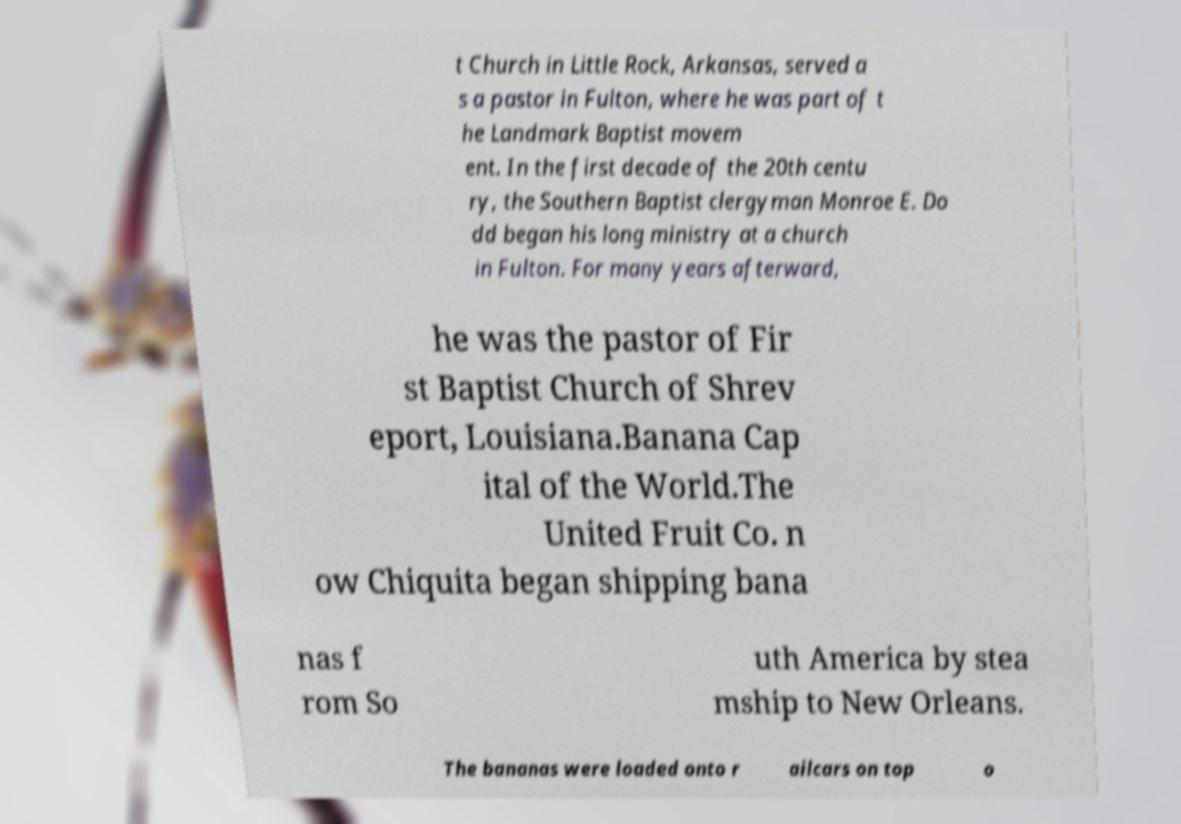Can you read and provide the text displayed in the image?This photo seems to have some interesting text. Can you extract and type it out for me? t Church in Little Rock, Arkansas, served a s a pastor in Fulton, where he was part of t he Landmark Baptist movem ent. In the first decade of the 20th centu ry, the Southern Baptist clergyman Monroe E. Do dd began his long ministry at a church in Fulton. For many years afterward, he was the pastor of Fir st Baptist Church of Shrev eport, Louisiana.Banana Cap ital of the World.The United Fruit Co. n ow Chiquita began shipping bana nas f rom So uth America by stea mship to New Orleans. The bananas were loaded onto r ailcars on top o 